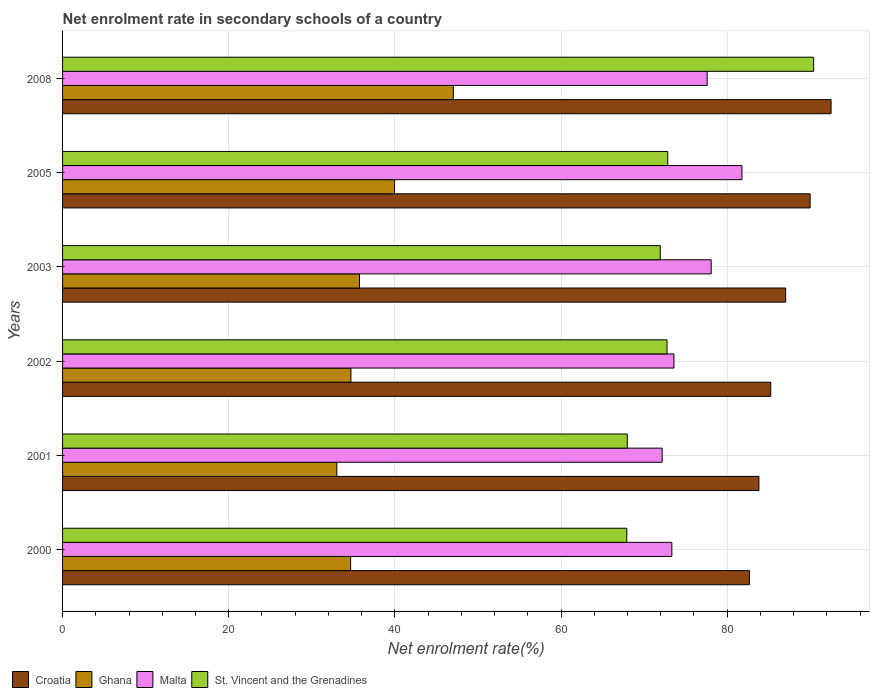How many different coloured bars are there?
Provide a short and direct response. 4. Are the number of bars per tick equal to the number of legend labels?
Give a very brief answer. Yes. What is the label of the 4th group of bars from the top?
Your response must be concise. 2002. What is the net enrolment rate in secondary schools in Croatia in 2000?
Give a very brief answer. 82.68. Across all years, what is the maximum net enrolment rate in secondary schools in St. Vincent and the Grenadines?
Give a very brief answer. 90.41. Across all years, what is the minimum net enrolment rate in secondary schools in St. Vincent and the Grenadines?
Ensure brevity in your answer.  67.92. In which year was the net enrolment rate in secondary schools in Croatia minimum?
Your answer should be very brief. 2000. What is the total net enrolment rate in secondary schools in Malta in the graph?
Provide a succinct answer. 456.56. What is the difference between the net enrolment rate in secondary schools in Croatia in 2002 and that in 2008?
Give a very brief answer. -7.26. What is the difference between the net enrolment rate in secondary schools in Malta in 2000 and the net enrolment rate in secondary schools in Ghana in 2001?
Offer a terse response. 40.33. What is the average net enrolment rate in secondary schools in Croatia per year?
Offer a very short reply. 86.88. In the year 2008, what is the difference between the net enrolment rate in secondary schools in Croatia and net enrolment rate in secondary schools in Ghana?
Make the answer very short. 45.47. What is the ratio of the net enrolment rate in secondary schools in Malta in 2002 to that in 2003?
Keep it short and to the point. 0.94. Is the difference between the net enrolment rate in secondary schools in Croatia in 2002 and 2008 greater than the difference between the net enrolment rate in secondary schools in Ghana in 2002 and 2008?
Your answer should be very brief. Yes. What is the difference between the highest and the second highest net enrolment rate in secondary schools in Croatia?
Provide a short and direct response. 2.52. What is the difference between the highest and the lowest net enrolment rate in secondary schools in Malta?
Offer a terse response. 9.6. What does the 2nd bar from the top in 2000 represents?
Keep it short and to the point. Malta. What does the 2nd bar from the bottom in 2001 represents?
Offer a terse response. Ghana. What is the difference between two consecutive major ticks on the X-axis?
Provide a succinct answer. 20. Are the values on the major ticks of X-axis written in scientific E-notation?
Offer a very short reply. No. Does the graph contain any zero values?
Your answer should be very brief. No. Does the graph contain grids?
Give a very brief answer. Yes. How are the legend labels stacked?
Ensure brevity in your answer.  Horizontal. What is the title of the graph?
Your response must be concise. Net enrolment rate in secondary schools of a country. What is the label or title of the X-axis?
Your answer should be compact. Net enrolment rate(%). What is the Net enrolment rate(%) of Croatia in 2000?
Ensure brevity in your answer.  82.68. What is the Net enrolment rate(%) in Ghana in 2000?
Offer a very short reply. 34.68. What is the Net enrolment rate(%) in Malta in 2000?
Give a very brief answer. 73.34. What is the Net enrolment rate(%) of St. Vincent and the Grenadines in 2000?
Keep it short and to the point. 67.92. What is the Net enrolment rate(%) of Croatia in 2001?
Provide a succinct answer. 83.82. What is the Net enrolment rate(%) in Ghana in 2001?
Give a very brief answer. 33.01. What is the Net enrolment rate(%) of Malta in 2001?
Your answer should be very brief. 72.17. What is the Net enrolment rate(%) in St. Vincent and the Grenadines in 2001?
Offer a very short reply. 67.98. What is the Net enrolment rate(%) in Croatia in 2002?
Offer a terse response. 85.25. What is the Net enrolment rate(%) of Ghana in 2002?
Keep it short and to the point. 34.71. What is the Net enrolment rate(%) of Malta in 2002?
Make the answer very short. 73.6. What is the Net enrolment rate(%) in St. Vincent and the Grenadines in 2002?
Your answer should be very brief. 72.76. What is the Net enrolment rate(%) of Croatia in 2003?
Your answer should be very brief. 87.04. What is the Net enrolment rate(%) in Ghana in 2003?
Keep it short and to the point. 35.74. What is the Net enrolment rate(%) in Malta in 2003?
Provide a short and direct response. 78.08. What is the Net enrolment rate(%) in St. Vincent and the Grenadines in 2003?
Provide a short and direct response. 71.95. What is the Net enrolment rate(%) in Croatia in 2005?
Offer a terse response. 89.99. What is the Net enrolment rate(%) in Ghana in 2005?
Give a very brief answer. 39.97. What is the Net enrolment rate(%) of Malta in 2005?
Offer a very short reply. 81.78. What is the Net enrolment rate(%) of St. Vincent and the Grenadines in 2005?
Offer a terse response. 72.85. What is the Net enrolment rate(%) in Croatia in 2008?
Offer a terse response. 92.51. What is the Net enrolment rate(%) in Ghana in 2008?
Give a very brief answer. 47.04. What is the Net enrolment rate(%) of Malta in 2008?
Offer a terse response. 77.59. What is the Net enrolment rate(%) of St. Vincent and the Grenadines in 2008?
Provide a short and direct response. 90.41. Across all years, what is the maximum Net enrolment rate(%) in Croatia?
Keep it short and to the point. 92.51. Across all years, what is the maximum Net enrolment rate(%) in Ghana?
Provide a short and direct response. 47.04. Across all years, what is the maximum Net enrolment rate(%) of Malta?
Your answer should be compact. 81.78. Across all years, what is the maximum Net enrolment rate(%) in St. Vincent and the Grenadines?
Provide a succinct answer. 90.41. Across all years, what is the minimum Net enrolment rate(%) of Croatia?
Offer a terse response. 82.68. Across all years, what is the minimum Net enrolment rate(%) in Ghana?
Offer a very short reply. 33.01. Across all years, what is the minimum Net enrolment rate(%) of Malta?
Offer a terse response. 72.17. Across all years, what is the minimum Net enrolment rate(%) of St. Vincent and the Grenadines?
Your answer should be very brief. 67.92. What is the total Net enrolment rate(%) of Croatia in the graph?
Give a very brief answer. 521.29. What is the total Net enrolment rate(%) in Ghana in the graph?
Give a very brief answer. 225.15. What is the total Net enrolment rate(%) in Malta in the graph?
Provide a succinct answer. 456.56. What is the total Net enrolment rate(%) in St. Vincent and the Grenadines in the graph?
Keep it short and to the point. 443.86. What is the difference between the Net enrolment rate(%) in Croatia in 2000 and that in 2001?
Provide a succinct answer. -1.14. What is the difference between the Net enrolment rate(%) of Ghana in 2000 and that in 2001?
Keep it short and to the point. 1.67. What is the difference between the Net enrolment rate(%) in Malta in 2000 and that in 2001?
Give a very brief answer. 1.17. What is the difference between the Net enrolment rate(%) in St. Vincent and the Grenadines in 2000 and that in 2001?
Give a very brief answer. -0.06. What is the difference between the Net enrolment rate(%) in Croatia in 2000 and that in 2002?
Provide a short and direct response. -2.57. What is the difference between the Net enrolment rate(%) in Ghana in 2000 and that in 2002?
Give a very brief answer. -0.03. What is the difference between the Net enrolment rate(%) in Malta in 2000 and that in 2002?
Provide a succinct answer. -0.25. What is the difference between the Net enrolment rate(%) in St. Vincent and the Grenadines in 2000 and that in 2002?
Give a very brief answer. -4.85. What is the difference between the Net enrolment rate(%) in Croatia in 2000 and that in 2003?
Your answer should be compact. -4.36. What is the difference between the Net enrolment rate(%) in Ghana in 2000 and that in 2003?
Provide a short and direct response. -1.06. What is the difference between the Net enrolment rate(%) of Malta in 2000 and that in 2003?
Your response must be concise. -4.73. What is the difference between the Net enrolment rate(%) in St. Vincent and the Grenadines in 2000 and that in 2003?
Provide a succinct answer. -4.03. What is the difference between the Net enrolment rate(%) in Croatia in 2000 and that in 2005?
Keep it short and to the point. -7.31. What is the difference between the Net enrolment rate(%) in Ghana in 2000 and that in 2005?
Offer a terse response. -5.29. What is the difference between the Net enrolment rate(%) of Malta in 2000 and that in 2005?
Provide a short and direct response. -8.44. What is the difference between the Net enrolment rate(%) in St. Vincent and the Grenadines in 2000 and that in 2005?
Provide a short and direct response. -4.93. What is the difference between the Net enrolment rate(%) of Croatia in 2000 and that in 2008?
Ensure brevity in your answer.  -9.83. What is the difference between the Net enrolment rate(%) in Ghana in 2000 and that in 2008?
Ensure brevity in your answer.  -12.36. What is the difference between the Net enrolment rate(%) of Malta in 2000 and that in 2008?
Provide a short and direct response. -4.25. What is the difference between the Net enrolment rate(%) in St. Vincent and the Grenadines in 2000 and that in 2008?
Your answer should be compact. -22.49. What is the difference between the Net enrolment rate(%) in Croatia in 2001 and that in 2002?
Make the answer very short. -1.42. What is the difference between the Net enrolment rate(%) of Ghana in 2001 and that in 2002?
Your response must be concise. -1.7. What is the difference between the Net enrolment rate(%) in Malta in 2001 and that in 2002?
Give a very brief answer. -1.42. What is the difference between the Net enrolment rate(%) of St. Vincent and the Grenadines in 2001 and that in 2002?
Make the answer very short. -4.79. What is the difference between the Net enrolment rate(%) of Croatia in 2001 and that in 2003?
Your answer should be compact. -3.22. What is the difference between the Net enrolment rate(%) in Ghana in 2001 and that in 2003?
Your answer should be compact. -2.73. What is the difference between the Net enrolment rate(%) of Malta in 2001 and that in 2003?
Give a very brief answer. -5.9. What is the difference between the Net enrolment rate(%) of St. Vincent and the Grenadines in 2001 and that in 2003?
Offer a very short reply. -3.97. What is the difference between the Net enrolment rate(%) in Croatia in 2001 and that in 2005?
Your answer should be compact. -6.17. What is the difference between the Net enrolment rate(%) of Ghana in 2001 and that in 2005?
Your answer should be compact. -6.96. What is the difference between the Net enrolment rate(%) in Malta in 2001 and that in 2005?
Make the answer very short. -9.6. What is the difference between the Net enrolment rate(%) of St. Vincent and the Grenadines in 2001 and that in 2005?
Give a very brief answer. -4.87. What is the difference between the Net enrolment rate(%) of Croatia in 2001 and that in 2008?
Provide a short and direct response. -8.69. What is the difference between the Net enrolment rate(%) in Ghana in 2001 and that in 2008?
Your response must be concise. -14.03. What is the difference between the Net enrolment rate(%) of Malta in 2001 and that in 2008?
Your answer should be very brief. -5.42. What is the difference between the Net enrolment rate(%) in St. Vincent and the Grenadines in 2001 and that in 2008?
Provide a succinct answer. -22.43. What is the difference between the Net enrolment rate(%) in Croatia in 2002 and that in 2003?
Keep it short and to the point. -1.8. What is the difference between the Net enrolment rate(%) in Ghana in 2002 and that in 2003?
Ensure brevity in your answer.  -1.03. What is the difference between the Net enrolment rate(%) of Malta in 2002 and that in 2003?
Ensure brevity in your answer.  -4.48. What is the difference between the Net enrolment rate(%) of St. Vincent and the Grenadines in 2002 and that in 2003?
Offer a very short reply. 0.82. What is the difference between the Net enrolment rate(%) in Croatia in 2002 and that in 2005?
Make the answer very short. -4.74. What is the difference between the Net enrolment rate(%) in Ghana in 2002 and that in 2005?
Make the answer very short. -5.26. What is the difference between the Net enrolment rate(%) in Malta in 2002 and that in 2005?
Your answer should be compact. -8.18. What is the difference between the Net enrolment rate(%) of St. Vincent and the Grenadines in 2002 and that in 2005?
Your response must be concise. -0.09. What is the difference between the Net enrolment rate(%) of Croatia in 2002 and that in 2008?
Offer a very short reply. -7.26. What is the difference between the Net enrolment rate(%) of Ghana in 2002 and that in 2008?
Provide a succinct answer. -12.33. What is the difference between the Net enrolment rate(%) of Malta in 2002 and that in 2008?
Your response must be concise. -4. What is the difference between the Net enrolment rate(%) of St. Vincent and the Grenadines in 2002 and that in 2008?
Ensure brevity in your answer.  -17.65. What is the difference between the Net enrolment rate(%) in Croatia in 2003 and that in 2005?
Offer a very short reply. -2.95. What is the difference between the Net enrolment rate(%) of Ghana in 2003 and that in 2005?
Give a very brief answer. -4.23. What is the difference between the Net enrolment rate(%) of Malta in 2003 and that in 2005?
Make the answer very short. -3.7. What is the difference between the Net enrolment rate(%) in St. Vincent and the Grenadines in 2003 and that in 2005?
Offer a terse response. -0.9. What is the difference between the Net enrolment rate(%) of Croatia in 2003 and that in 2008?
Ensure brevity in your answer.  -5.47. What is the difference between the Net enrolment rate(%) of Ghana in 2003 and that in 2008?
Offer a very short reply. -11.3. What is the difference between the Net enrolment rate(%) in Malta in 2003 and that in 2008?
Provide a short and direct response. 0.48. What is the difference between the Net enrolment rate(%) in St. Vincent and the Grenadines in 2003 and that in 2008?
Provide a succinct answer. -18.46. What is the difference between the Net enrolment rate(%) in Croatia in 2005 and that in 2008?
Offer a terse response. -2.52. What is the difference between the Net enrolment rate(%) in Ghana in 2005 and that in 2008?
Offer a very short reply. -7.07. What is the difference between the Net enrolment rate(%) of Malta in 2005 and that in 2008?
Keep it short and to the point. 4.19. What is the difference between the Net enrolment rate(%) in St. Vincent and the Grenadines in 2005 and that in 2008?
Give a very brief answer. -17.56. What is the difference between the Net enrolment rate(%) in Croatia in 2000 and the Net enrolment rate(%) in Ghana in 2001?
Ensure brevity in your answer.  49.67. What is the difference between the Net enrolment rate(%) in Croatia in 2000 and the Net enrolment rate(%) in Malta in 2001?
Ensure brevity in your answer.  10.51. What is the difference between the Net enrolment rate(%) in Croatia in 2000 and the Net enrolment rate(%) in St. Vincent and the Grenadines in 2001?
Your answer should be very brief. 14.7. What is the difference between the Net enrolment rate(%) of Ghana in 2000 and the Net enrolment rate(%) of Malta in 2001?
Give a very brief answer. -37.5. What is the difference between the Net enrolment rate(%) in Ghana in 2000 and the Net enrolment rate(%) in St. Vincent and the Grenadines in 2001?
Provide a short and direct response. -33.3. What is the difference between the Net enrolment rate(%) of Malta in 2000 and the Net enrolment rate(%) of St. Vincent and the Grenadines in 2001?
Provide a short and direct response. 5.37. What is the difference between the Net enrolment rate(%) in Croatia in 2000 and the Net enrolment rate(%) in Ghana in 2002?
Your answer should be compact. 47.97. What is the difference between the Net enrolment rate(%) of Croatia in 2000 and the Net enrolment rate(%) of Malta in 2002?
Offer a terse response. 9.08. What is the difference between the Net enrolment rate(%) of Croatia in 2000 and the Net enrolment rate(%) of St. Vincent and the Grenadines in 2002?
Your response must be concise. 9.92. What is the difference between the Net enrolment rate(%) of Ghana in 2000 and the Net enrolment rate(%) of Malta in 2002?
Make the answer very short. -38.92. What is the difference between the Net enrolment rate(%) of Ghana in 2000 and the Net enrolment rate(%) of St. Vincent and the Grenadines in 2002?
Provide a succinct answer. -38.08. What is the difference between the Net enrolment rate(%) in Malta in 2000 and the Net enrolment rate(%) in St. Vincent and the Grenadines in 2002?
Offer a terse response. 0.58. What is the difference between the Net enrolment rate(%) of Croatia in 2000 and the Net enrolment rate(%) of Ghana in 2003?
Your response must be concise. 46.94. What is the difference between the Net enrolment rate(%) in Croatia in 2000 and the Net enrolment rate(%) in Malta in 2003?
Offer a very short reply. 4.6. What is the difference between the Net enrolment rate(%) of Croatia in 2000 and the Net enrolment rate(%) of St. Vincent and the Grenadines in 2003?
Your answer should be very brief. 10.73. What is the difference between the Net enrolment rate(%) in Ghana in 2000 and the Net enrolment rate(%) in Malta in 2003?
Your response must be concise. -43.4. What is the difference between the Net enrolment rate(%) in Ghana in 2000 and the Net enrolment rate(%) in St. Vincent and the Grenadines in 2003?
Keep it short and to the point. -37.27. What is the difference between the Net enrolment rate(%) in Malta in 2000 and the Net enrolment rate(%) in St. Vincent and the Grenadines in 2003?
Offer a very short reply. 1.39. What is the difference between the Net enrolment rate(%) in Croatia in 2000 and the Net enrolment rate(%) in Ghana in 2005?
Your response must be concise. 42.71. What is the difference between the Net enrolment rate(%) of Croatia in 2000 and the Net enrolment rate(%) of Malta in 2005?
Your answer should be very brief. 0.9. What is the difference between the Net enrolment rate(%) in Croatia in 2000 and the Net enrolment rate(%) in St. Vincent and the Grenadines in 2005?
Your response must be concise. 9.83. What is the difference between the Net enrolment rate(%) in Ghana in 2000 and the Net enrolment rate(%) in Malta in 2005?
Your answer should be very brief. -47.1. What is the difference between the Net enrolment rate(%) in Ghana in 2000 and the Net enrolment rate(%) in St. Vincent and the Grenadines in 2005?
Your response must be concise. -38.17. What is the difference between the Net enrolment rate(%) of Malta in 2000 and the Net enrolment rate(%) of St. Vincent and the Grenadines in 2005?
Your response must be concise. 0.49. What is the difference between the Net enrolment rate(%) in Croatia in 2000 and the Net enrolment rate(%) in Ghana in 2008?
Offer a terse response. 35.64. What is the difference between the Net enrolment rate(%) of Croatia in 2000 and the Net enrolment rate(%) of Malta in 2008?
Your response must be concise. 5.09. What is the difference between the Net enrolment rate(%) in Croatia in 2000 and the Net enrolment rate(%) in St. Vincent and the Grenadines in 2008?
Give a very brief answer. -7.73. What is the difference between the Net enrolment rate(%) of Ghana in 2000 and the Net enrolment rate(%) of Malta in 2008?
Your answer should be very brief. -42.91. What is the difference between the Net enrolment rate(%) in Ghana in 2000 and the Net enrolment rate(%) in St. Vincent and the Grenadines in 2008?
Your answer should be compact. -55.73. What is the difference between the Net enrolment rate(%) of Malta in 2000 and the Net enrolment rate(%) of St. Vincent and the Grenadines in 2008?
Offer a terse response. -17.07. What is the difference between the Net enrolment rate(%) of Croatia in 2001 and the Net enrolment rate(%) of Ghana in 2002?
Make the answer very short. 49.11. What is the difference between the Net enrolment rate(%) of Croatia in 2001 and the Net enrolment rate(%) of Malta in 2002?
Your answer should be compact. 10.23. What is the difference between the Net enrolment rate(%) in Croatia in 2001 and the Net enrolment rate(%) in St. Vincent and the Grenadines in 2002?
Offer a terse response. 11.06. What is the difference between the Net enrolment rate(%) in Ghana in 2001 and the Net enrolment rate(%) in Malta in 2002?
Ensure brevity in your answer.  -40.58. What is the difference between the Net enrolment rate(%) in Ghana in 2001 and the Net enrolment rate(%) in St. Vincent and the Grenadines in 2002?
Your answer should be compact. -39.75. What is the difference between the Net enrolment rate(%) in Malta in 2001 and the Net enrolment rate(%) in St. Vincent and the Grenadines in 2002?
Your answer should be very brief. -0.59. What is the difference between the Net enrolment rate(%) in Croatia in 2001 and the Net enrolment rate(%) in Ghana in 2003?
Offer a very short reply. 48.08. What is the difference between the Net enrolment rate(%) in Croatia in 2001 and the Net enrolment rate(%) in Malta in 2003?
Your answer should be compact. 5.75. What is the difference between the Net enrolment rate(%) in Croatia in 2001 and the Net enrolment rate(%) in St. Vincent and the Grenadines in 2003?
Your response must be concise. 11.88. What is the difference between the Net enrolment rate(%) of Ghana in 2001 and the Net enrolment rate(%) of Malta in 2003?
Make the answer very short. -45.06. What is the difference between the Net enrolment rate(%) in Ghana in 2001 and the Net enrolment rate(%) in St. Vincent and the Grenadines in 2003?
Your answer should be compact. -38.94. What is the difference between the Net enrolment rate(%) in Malta in 2001 and the Net enrolment rate(%) in St. Vincent and the Grenadines in 2003?
Offer a very short reply. 0.23. What is the difference between the Net enrolment rate(%) of Croatia in 2001 and the Net enrolment rate(%) of Ghana in 2005?
Your answer should be very brief. 43.85. What is the difference between the Net enrolment rate(%) in Croatia in 2001 and the Net enrolment rate(%) in Malta in 2005?
Your response must be concise. 2.04. What is the difference between the Net enrolment rate(%) in Croatia in 2001 and the Net enrolment rate(%) in St. Vincent and the Grenadines in 2005?
Give a very brief answer. 10.97. What is the difference between the Net enrolment rate(%) in Ghana in 2001 and the Net enrolment rate(%) in Malta in 2005?
Give a very brief answer. -48.77. What is the difference between the Net enrolment rate(%) of Ghana in 2001 and the Net enrolment rate(%) of St. Vincent and the Grenadines in 2005?
Offer a very short reply. -39.84. What is the difference between the Net enrolment rate(%) of Malta in 2001 and the Net enrolment rate(%) of St. Vincent and the Grenadines in 2005?
Give a very brief answer. -0.68. What is the difference between the Net enrolment rate(%) of Croatia in 2001 and the Net enrolment rate(%) of Ghana in 2008?
Offer a very short reply. 36.78. What is the difference between the Net enrolment rate(%) in Croatia in 2001 and the Net enrolment rate(%) in Malta in 2008?
Make the answer very short. 6.23. What is the difference between the Net enrolment rate(%) in Croatia in 2001 and the Net enrolment rate(%) in St. Vincent and the Grenadines in 2008?
Ensure brevity in your answer.  -6.59. What is the difference between the Net enrolment rate(%) in Ghana in 2001 and the Net enrolment rate(%) in Malta in 2008?
Provide a short and direct response. -44.58. What is the difference between the Net enrolment rate(%) of Ghana in 2001 and the Net enrolment rate(%) of St. Vincent and the Grenadines in 2008?
Your answer should be compact. -57.4. What is the difference between the Net enrolment rate(%) of Malta in 2001 and the Net enrolment rate(%) of St. Vincent and the Grenadines in 2008?
Make the answer very short. -18.24. What is the difference between the Net enrolment rate(%) of Croatia in 2002 and the Net enrolment rate(%) of Ghana in 2003?
Your answer should be compact. 49.51. What is the difference between the Net enrolment rate(%) of Croatia in 2002 and the Net enrolment rate(%) of Malta in 2003?
Keep it short and to the point. 7.17. What is the difference between the Net enrolment rate(%) in Croatia in 2002 and the Net enrolment rate(%) in St. Vincent and the Grenadines in 2003?
Your answer should be very brief. 13.3. What is the difference between the Net enrolment rate(%) in Ghana in 2002 and the Net enrolment rate(%) in Malta in 2003?
Your answer should be very brief. -43.36. What is the difference between the Net enrolment rate(%) in Ghana in 2002 and the Net enrolment rate(%) in St. Vincent and the Grenadines in 2003?
Offer a terse response. -37.24. What is the difference between the Net enrolment rate(%) of Malta in 2002 and the Net enrolment rate(%) of St. Vincent and the Grenadines in 2003?
Make the answer very short. 1.65. What is the difference between the Net enrolment rate(%) of Croatia in 2002 and the Net enrolment rate(%) of Ghana in 2005?
Offer a very short reply. 45.28. What is the difference between the Net enrolment rate(%) in Croatia in 2002 and the Net enrolment rate(%) in Malta in 2005?
Your answer should be very brief. 3.47. What is the difference between the Net enrolment rate(%) of Croatia in 2002 and the Net enrolment rate(%) of St. Vincent and the Grenadines in 2005?
Your response must be concise. 12.4. What is the difference between the Net enrolment rate(%) of Ghana in 2002 and the Net enrolment rate(%) of Malta in 2005?
Offer a very short reply. -47.07. What is the difference between the Net enrolment rate(%) of Ghana in 2002 and the Net enrolment rate(%) of St. Vincent and the Grenadines in 2005?
Provide a short and direct response. -38.14. What is the difference between the Net enrolment rate(%) of Malta in 2002 and the Net enrolment rate(%) of St. Vincent and the Grenadines in 2005?
Ensure brevity in your answer.  0.74. What is the difference between the Net enrolment rate(%) in Croatia in 2002 and the Net enrolment rate(%) in Ghana in 2008?
Ensure brevity in your answer.  38.21. What is the difference between the Net enrolment rate(%) in Croatia in 2002 and the Net enrolment rate(%) in Malta in 2008?
Offer a very short reply. 7.65. What is the difference between the Net enrolment rate(%) in Croatia in 2002 and the Net enrolment rate(%) in St. Vincent and the Grenadines in 2008?
Your answer should be very brief. -5.16. What is the difference between the Net enrolment rate(%) in Ghana in 2002 and the Net enrolment rate(%) in Malta in 2008?
Your response must be concise. -42.88. What is the difference between the Net enrolment rate(%) of Ghana in 2002 and the Net enrolment rate(%) of St. Vincent and the Grenadines in 2008?
Your response must be concise. -55.7. What is the difference between the Net enrolment rate(%) in Malta in 2002 and the Net enrolment rate(%) in St. Vincent and the Grenadines in 2008?
Keep it short and to the point. -16.82. What is the difference between the Net enrolment rate(%) in Croatia in 2003 and the Net enrolment rate(%) in Ghana in 2005?
Offer a terse response. 47.07. What is the difference between the Net enrolment rate(%) in Croatia in 2003 and the Net enrolment rate(%) in Malta in 2005?
Ensure brevity in your answer.  5.26. What is the difference between the Net enrolment rate(%) in Croatia in 2003 and the Net enrolment rate(%) in St. Vincent and the Grenadines in 2005?
Your answer should be very brief. 14.19. What is the difference between the Net enrolment rate(%) in Ghana in 2003 and the Net enrolment rate(%) in Malta in 2005?
Keep it short and to the point. -46.04. What is the difference between the Net enrolment rate(%) in Ghana in 2003 and the Net enrolment rate(%) in St. Vincent and the Grenadines in 2005?
Keep it short and to the point. -37.11. What is the difference between the Net enrolment rate(%) in Malta in 2003 and the Net enrolment rate(%) in St. Vincent and the Grenadines in 2005?
Provide a succinct answer. 5.22. What is the difference between the Net enrolment rate(%) of Croatia in 2003 and the Net enrolment rate(%) of Ghana in 2008?
Provide a succinct answer. 40. What is the difference between the Net enrolment rate(%) of Croatia in 2003 and the Net enrolment rate(%) of Malta in 2008?
Ensure brevity in your answer.  9.45. What is the difference between the Net enrolment rate(%) of Croatia in 2003 and the Net enrolment rate(%) of St. Vincent and the Grenadines in 2008?
Give a very brief answer. -3.37. What is the difference between the Net enrolment rate(%) in Ghana in 2003 and the Net enrolment rate(%) in Malta in 2008?
Provide a succinct answer. -41.85. What is the difference between the Net enrolment rate(%) in Ghana in 2003 and the Net enrolment rate(%) in St. Vincent and the Grenadines in 2008?
Your answer should be compact. -54.67. What is the difference between the Net enrolment rate(%) in Malta in 2003 and the Net enrolment rate(%) in St. Vincent and the Grenadines in 2008?
Your answer should be very brief. -12.33. What is the difference between the Net enrolment rate(%) in Croatia in 2005 and the Net enrolment rate(%) in Ghana in 2008?
Provide a succinct answer. 42.95. What is the difference between the Net enrolment rate(%) of Croatia in 2005 and the Net enrolment rate(%) of Malta in 2008?
Offer a very short reply. 12.4. What is the difference between the Net enrolment rate(%) of Croatia in 2005 and the Net enrolment rate(%) of St. Vincent and the Grenadines in 2008?
Make the answer very short. -0.42. What is the difference between the Net enrolment rate(%) in Ghana in 2005 and the Net enrolment rate(%) in Malta in 2008?
Provide a short and direct response. -37.62. What is the difference between the Net enrolment rate(%) in Ghana in 2005 and the Net enrolment rate(%) in St. Vincent and the Grenadines in 2008?
Provide a short and direct response. -50.44. What is the difference between the Net enrolment rate(%) in Malta in 2005 and the Net enrolment rate(%) in St. Vincent and the Grenadines in 2008?
Your response must be concise. -8.63. What is the average Net enrolment rate(%) of Croatia per year?
Provide a succinct answer. 86.88. What is the average Net enrolment rate(%) in Ghana per year?
Your answer should be compact. 37.52. What is the average Net enrolment rate(%) of Malta per year?
Offer a very short reply. 76.09. What is the average Net enrolment rate(%) in St. Vincent and the Grenadines per year?
Your answer should be compact. 73.98. In the year 2000, what is the difference between the Net enrolment rate(%) of Croatia and Net enrolment rate(%) of Ghana?
Provide a succinct answer. 48. In the year 2000, what is the difference between the Net enrolment rate(%) of Croatia and Net enrolment rate(%) of Malta?
Give a very brief answer. 9.34. In the year 2000, what is the difference between the Net enrolment rate(%) of Croatia and Net enrolment rate(%) of St. Vincent and the Grenadines?
Ensure brevity in your answer.  14.76. In the year 2000, what is the difference between the Net enrolment rate(%) in Ghana and Net enrolment rate(%) in Malta?
Your answer should be compact. -38.66. In the year 2000, what is the difference between the Net enrolment rate(%) in Ghana and Net enrolment rate(%) in St. Vincent and the Grenadines?
Ensure brevity in your answer.  -33.24. In the year 2000, what is the difference between the Net enrolment rate(%) of Malta and Net enrolment rate(%) of St. Vincent and the Grenadines?
Provide a short and direct response. 5.42. In the year 2001, what is the difference between the Net enrolment rate(%) in Croatia and Net enrolment rate(%) in Ghana?
Keep it short and to the point. 50.81. In the year 2001, what is the difference between the Net enrolment rate(%) in Croatia and Net enrolment rate(%) in Malta?
Your answer should be very brief. 11.65. In the year 2001, what is the difference between the Net enrolment rate(%) of Croatia and Net enrolment rate(%) of St. Vincent and the Grenadines?
Ensure brevity in your answer.  15.85. In the year 2001, what is the difference between the Net enrolment rate(%) in Ghana and Net enrolment rate(%) in Malta?
Provide a short and direct response. -39.16. In the year 2001, what is the difference between the Net enrolment rate(%) in Ghana and Net enrolment rate(%) in St. Vincent and the Grenadines?
Your response must be concise. -34.96. In the year 2001, what is the difference between the Net enrolment rate(%) of Malta and Net enrolment rate(%) of St. Vincent and the Grenadines?
Make the answer very short. 4.2. In the year 2002, what is the difference between the Net enrolment rate(%) of Croatia and Net enrolment rate(%) of Ghana?
Provide a succinct answer. 50.53. In the year 2002, what is the difference between the Net enrolment rate(%) in Croatia and Net enrolment rate(%) in Malta?
Offer a very short reply. 11.65. In the year 2002, what is the difference between the Net enrolment rate(%) of Croatia and Net enrolment rate(%) of St. Vincent and the Grenadines?
Your answer should be very brief. 12.48. In the year 2002, what is the difference between the Net enrolment rate(%) of Ghana and Net enrolment rate(%) of Malta?
Your answer should be very brief. -38.88. In the year 2002, what is the difference between the Net enrolment rate(%) in Ghana and Net enrolment rate(%) in St. Vincent and the Grenadines?
Your answer should be compact. -38.05. In the year 2002, what is the difference between the Net enrolment rate(%) of Malta and Net enrolment rate(%) of St. Vincent and the Grenadines?
Ensure brevity in your answer.  0.83. In the year 2003, what is the difference between the Net enrolment rate(%) in Croatia and Net enrolment rate(%) in Ghana?
Offer a very short reply. 51.3. In the year 2003, what is the difference between the Net enrolment rate(%) in Croatia and Net enrolment rate(%) in Malta?
Offer a terse response. 8.97. In the year 2003, what is the difference between the Net enrolment rate(%) of Croatia and Net enrolment rate(%) of St. Vincent and the Grenadines?
Keep it short and to the point. 15.09. In the year 2003, what is the difference between the Net enrolment rate(%) of Ghana and Net enrolment rate(%) of Malta?
Offer a terse response. -42.34. In the year 2003, what is the difference between the Net enrolment rate(%) in Ghana and Net enrolment rate(%) in St. Vincent and the Grenadines?
Provide a succinct answer. -36.21. In the year 2003, what is the difference between the Net enrolment rate(%) of Malta and Net enrolment rate(%) of St. Vincent and the Grenadines?
Provide a short and direct response. 6.13. In the year 2005, what is the difference between the Net enrolment rate(%) in Croatia and Net enrolment rate(%) in Ghana?
Provide a short and direct response. 50.02. In the year 2005, what is the difference between the Net enrolment rate(%) in Croatia and Net enrolment rate(%) in Malta?
Offer a terse response. 8.21. In the year 2005, what is the difference between the Net enrolment rate(%) in Croatia and Net enrolment rate(%) in St. Vincent and the Grenadines?
Make the answer very short. 17.14. In the year 2005, what is the difference between the Net enrolment rate(%) in Ghana and Net enrolment rate(%) in Malta?
Provide a succinct answer. -41.81. In the year 2005, what is the difference between the Net enrolment rate(%) of Ghana and Net enrolment rate(%) of St. Vincent and the Grenadines?
Your answer should be very brief. -32.88. In the year 2005, what is the difference between the Net enrolment rate(%) of Malta and Net enrolment rate(%) of St. Vincent and the Grenadines?
Your answer should be compact. 8.93. In the year 2008, what is the difference between the Net enrolment rate(%) of Croatia and Net enrolment rate(%) of Ghana?
Ensure brevity in your answer.  45.47. In the year 2008, what is the difference between the Net enrolment rate(%) of Croatia and Net enrolment rate(%) of Malta?
Your answer should be very brief. 14.92. In the year 2008, what is the difference between the Net enrolment rate(%) of Croatia and Net enrolment rate(%) of St. Vincent and the Grenadines?
Your answer should be compact. 2.1. In the year 2008, what is the difference between the Net enrolment rate(%) in Ghana and Net enrolment rate(%) in Malta?
Your response must be concise. -30.55. In the year 2008, what is the difference between the Net enrolment rate(%) of Ghana and Net enrolment rate(%) of St. Vincent and the Grenadines?
Ensure brevity in your answer.  -43.37. In the year 2008, what is the difference between the Net enrolment rate(%) in Malta and Net enrolment rate(%) in St. Vincent and the Grenadines?
Make the answer very short. -12.82. What is the ratio of the Net enrolment rate(%) of Croatia in 2000 to that in 2001?
Make the answer very short. 0.99. What is the ratio of the Net enrolment rate(%) of Ghana in 2000 to that in 2001?
Your answer should be compact. 1.05. What is the ratio of the Net enrolment rate(%) in Malta in 2000 to that in 2001?
Your answer should be compact. 1.02. What is the ratio of the Net enrolment rate(%) of St. Vincent and the Grenadines in 2000 to that in 2001?
Provide a succinct answer. 1. What is the ratio of the Net enrolment rate(%) of Croatia in 2000 to that in 2002?
Your response must be concise. 0.97. What is the ratio of the Net enrolment rate(%) of Ghana in 2000 to that in 2002?
Give a very brief answer. 1. What is the ratio of the Net enrolment rate(%) of Malta in 2000 to that in 2002?
Offer a very short reply. 1. What is the ratio of the Net enrolment rate(%) in St. Vincent and the Grenadines in 2000 to that in 2002?
Your answer should be very brief. 0.93. What is the ratio of the Net enrolment rate(%) in Croatia in 2000 to that in 2003?
Make the answer very short. 0.95. What is the ratio of the Net enrolment rate(%) of Ghana in 2000 to that in 2003?
Ensure brevity in your answer.  0.97. What is the ratio of the Net enrolment rate(%) in Malta in 2000 to that in 2003?
Offer a terse response. 0.94. What is the ratio of the Net enrolment rate(%) in St. Vincent and the Grenadines in 2000 to that in 2003?
Offer a very short reply. 0.94. What is the ratio of the Net enrolment rate(%) of Croatia in 2000 to that in 2005?
Provide a succinct answer. 0.92. What is the ratio of the Net enrolment rate(%) in Ghana in 2000 to that in 2005?
Give a very brief answer. 0.87. What is the ratio of the Net enrolment rate(%) of Malta in 2000 to that in 2005?
Provide a short and direct response. 0.9. What is the ratio of the Net enrolment rate(%) in St. Vincent and the Grenadines in 2000 to that in 2005?
Give a very brief answer. 0.93. What is the ratio of the Net enrolment rate(%) in Croatia in 2000 to that in 2008?
Your answer should be very brief. 0.89. What is the ratio of the Net enrolment rate(%) in Ghana in 2000 to that in 2008?
Keep it short and to the point. 0.74. What is the ratio of the Net enrolment rate(%) of Malta in 2000 to that in 2008?
Give a very brief answer. 0.95. What is the ratio of the Net enrolment rate(%) in St. Vincent and the Grenadines in 2000 to that in 2008?
Provide a short and direct response. 0.75. What is the ratio of the Net enrolment rate(%) in Croatia in 2001 to that in 2002?
Provide a short and direct response. 0.98. What is the ratio of the Net enrolment rate(%) of Ghana in 2001 to that in 2002?
Make the answer very short. 0.95. What is the ratio of the Net enrolment rate(%) of Malta in 2001 to that in 2002?
Your response must be concise. 0.98. What is the ratio of the Net enrolment rate(%) of St. Vincent and the Grenadines in 2001 to that in 2002?
Make the answer very short. 0.93. What is the ratio of the Net enrolment rate(%) in Croatia in 2001 to that in 2003?
Your answer should be compact. 0.96. What is the ratio of the Net enrolment rate(%) of Ghana in 2001 to that in 2003?
Your response must be concise. 0.92. What is the ratio of the Net enrolment rate(%) in Malta in 2001 to that in 2003?
Provide a short and direct response. 0.92. What is the ratio of the Net enrolment rate(%) in St. Vincent and the Grenadines in 2001 to that in 2003?
Provide a short and direct response. 0.94. What is the ratio of the Net enrolment rate(%) in Croatia in 2001 to that in 2005?
Offer a very short reply. 0.93. What is the ratio of the Net enrolment rate(%) in Ghana in 2001 to that in 2005?
Offer a terse response. 0.83. What is the ratio of the Net enrolment rate(%) in Malta in 2001 to that in 2005?
Provide a succinct answer. 0.88. What is the ratio of the Net enrolment rate(%) of St. Vincent and the Grenadines in 2001 to that in 2005?
Ensure brevity in your answer.  0.93. What is the ratio of the Net enrolment rate(%) of Croatia in 2001 to that in 2008?
Keep it short and to the point. 0.91. What is the ratio of the Net enrolment rate(%) of Ghana in 2001 to that in 2008?
Your response must be concise. 0.7. What is the ratio of the Net enrolment rate(%) of Malta in 2001 to that in 2008?
Provide a short and direct response. 0.93. What is the ratio of the Net enrolment rate(%) in St. Vincent and the Grenadines in 2001 to that in 2008?
Offer a terse response. 0.75. What is the ratio of the Net enrolment rate(%) in Croatia in 2002 to that in 2003?
Your answer should be compact. 0.98. What is the ratio of the Net enrolment rate(%) of Ghana in 2002 to that in 2003?
Your answer should be very brief. 0.97. What is the ratio of the Net enrolment rate(%) of Malta in 2002 to that in 2003?
Provide a succinct answer. 0.94. What is the ratio of the Net enrolment rate(%) of St. Vincent and the Grenadines in 2002 to that in 2003?
Provide a short and direct response. 1.01. What is the ratio of the Net enrolment rate(%) of Croatia in 2002 to that in 2005?
Offer a very short reply. 0.95. What is the ratio of the Net enrolment rate(%) in Ghana in 2002 to that in 2005?
Your answer should be compact. 0.87. What is the ratio of the Net enrolment rate(%) of Malta in 2002 to that in 2005?
Keep it short and to the point. 0.9. What is the ratio of the Net enrolment rate(%) in St. Vincent and the Grenadines in 2002 to that in 2005?
Offer a very short reply. 1. What is the ratio of the Net enrolment rate(%) of Croatia in 2002 to that in 2008?
Make the answer very short. 0.92. What is the ratio of the Net enrolment rate(%) of Ghana in 2002 to that in 2008?
Your answer should be compact. 0.74. What is the ratio of the Net enrolment rate(%) of Malta in 2002 to that in 2008?
Give a very brief answer. 0.95. What is the ratio of the Net enrolment rate(%) in St. Vincent and the Grenadines in 2002 to that in 2008?
Offer a very short reply. 0.8. What is the ratio of the Net enrolment rate(%) in Croatia in 2003 to that in 2005?
Offer a very short reply. 0.97. What is the ratio of the Net enrolment rate(%) of Ghana in 2003 to that in 2005?
Ensure brevity in your answer.  0.89. What is the ratio of the Net enrolment rate(%) in Malta in 2003 to that in 2005?
Provide a succinct answer. 0.95. What is the ratio of the Net enrolment rate(%) in St. Vincent and the Grenadines in 2003 to that in 2005?
Provide a succinct answer. 0.99. What is the ratio of the Net enrolment rate(%) of Croatia in 2003 to that in 2008?
Offer a very short reply. 0.94. What is the ratio of the Net enrolment rate(%) in Ghana in 2003 to that in 2008?
Offer a terse response. 0.76. What is the ratio of the Net enrolment rate(%) of Malta in 2003 to that in 2008?
Keep it short and to the point. 1.01. What is the ratio of the Net enrolment rate(%) in St. Vincent and the Grenadines in 2003 to that in 2008?
Give a very brief answer. 0.8. What is the ratio of the Net enrolment rate(%) of Croatia in 2005 to that in 2008?
Your answer should be compact. 0.97. What is the ratio of the Net enrolment rate(%) in Ghana in 2005 to that in 2008?
Keep it short and to the point. 0.85. What is the ratio of the Net enrolment rate(%) of Malta in 2005 to that in 2008?
Your answer should be compact. 1.05. What is the ratio of the Net enrolment rate(%) in St. Vincent and the Grenadines in 2005 to that in 2008?
Offer a terse response. 0.81. What is the difference between the highest and the second highest Net enrolment rate(%) in Croatia?
Your answer should be compact. 2.52. What is the difference between the highest and the second highest Net enrolment rate(%) of Ghana?
Offer a terse response. 7.07. What is the difference between the highest and the second highest Net enrolment rate(%) of Malta?
Offer a terse response. 3.7. What is the difference between the highest and the second highest Net enrolment rate(%) in St. Vincent and the Grenadines?
Your answer should be compact. 17.56. What is the difference between the highest and the lowest Net enrolment rate(%) in Croatia?
Give a very brief answer. 9.83. What is the difference between the highest and the lowest Net enrolment rate(%) of Ghana?
Your answer should be compact. 14.03. What is the difference between the highest and the lowest Net enrolment rate(%) in Malta?
Offer a very short reply. 9.6. What is the difference between the highest and the lowest Net enrolment rate(%) in St. Vincent and the Grenadines?
Offer a very short reply. 22.49. 